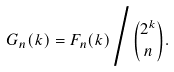Convert formula to latex. <formula><loc_0><loc_0><loc_500><loc_500>G _ { n } ( k ) = F _ { n } ( k ) \Big / { 2 ^ { k } \choose n } .</formula> 